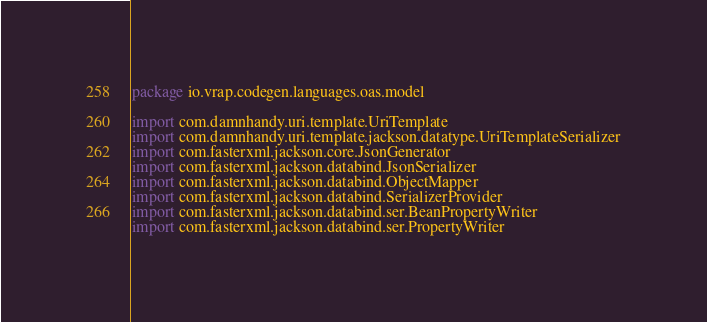Convert code to text. <code><loc_0><loc_0><loc_500><loc_500><_Kotlin_>package io.vrap.codegen.languages.oas.model

import com.damnhandy.uri.template.UriTemplate
import com.damnhandy.uri.template.jackson.datatype.UriTemplateSerializer
import com.fasterxml.jackson.core.JsonGenerator
import com.fasterxml.jackson.databind.JsonSerializer
import com.fasterxml.jackson.databind.ObjectMapper
import com.fasterxml.jackson.databind.SerializerProvider
import com.fasterxml.jackson.databind.ser.BeanPropertyWriter
import com.fasterxml.jackson.databind.ser.PropertyWriter</code> 